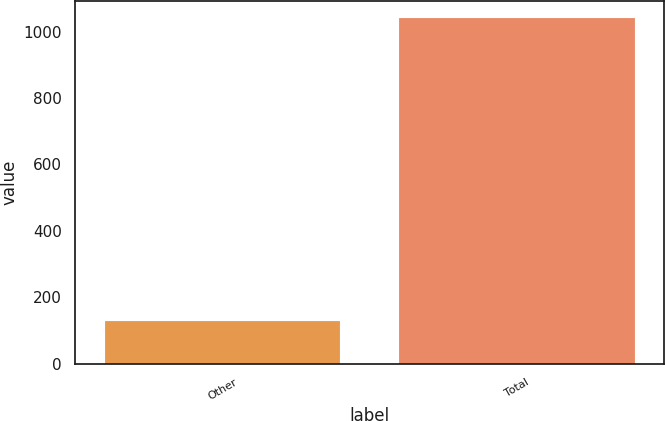Convert chart. <chart><loc_0><loc_0><loc_500><loc_500><bar_chart><fcel>Other<fcel>Total<nl><fcel>130<fcel>1040<nl></chart> 